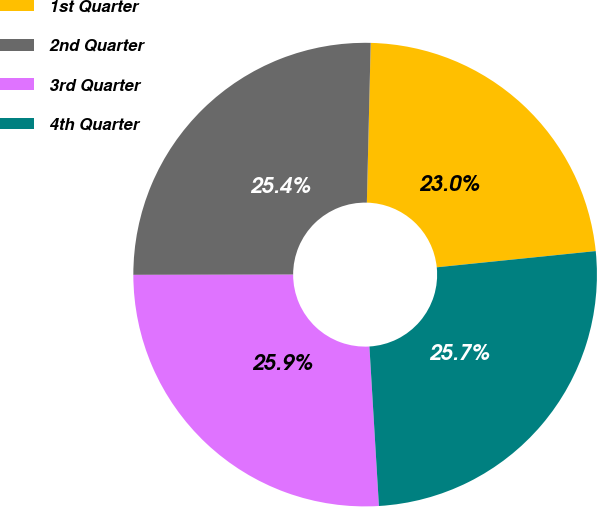Convert chart to OTSL. <chart><loc_0><loc_0><loc_500><loc_500><pie_chart><fcel>1st Quarter<fcel>2nd Quarter<fcel>3rd Quarter<fcel>4th Quarter<nl><fcel>23.0%<fcel>25.4%<fcel>25.93%<fcel>25.67%<nl></chart> 